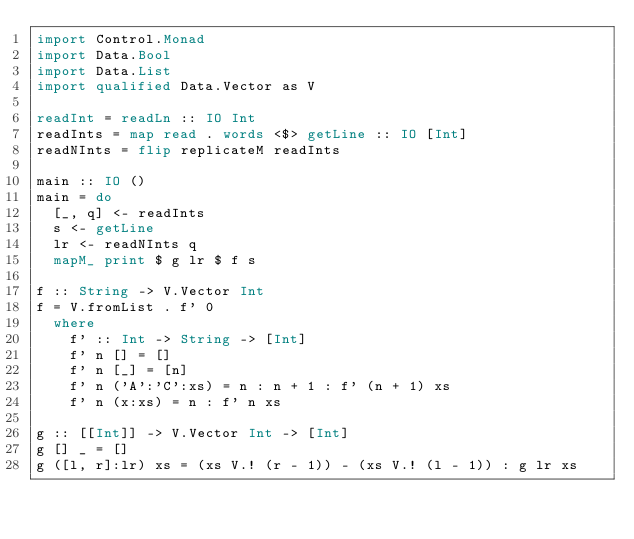Convert code to text. <code><loc_0><loc_0><loc_500><loc_500><_Haskell_>import Control.Monad
import Data.Bool
import Data.List
import qualified Data.Vector as V

readInt = readLn :: IO Int
readInts = map read . words <$> getLine :: IO [Int]
readNInts = flip replicateM readInts

main :: IO ()
main = do
  [_, q] <- readInts
  s <- getLine
  lr <- readNInts q
  mapM_ print $ g lr $ f s

f :: String -> V.Vector Int
f = V.fromList . f' 0
  where
    f' :: Int -> String -> [Int]
    f' n [] = []
    f' n [_] = [n]
    f' n ('A':'C':xs) = n : n + 1 : f' (n + 1) xs
    f' n (x:xs) = n : f' n xs

g :: [[Int]] -> V.Vector Int -> [Int]
g [] _ = []
g ([l, r]:lr) xs = (xs V.! (r - 1)) - (xs V.! (l - 1)) : g lr xs</code> 